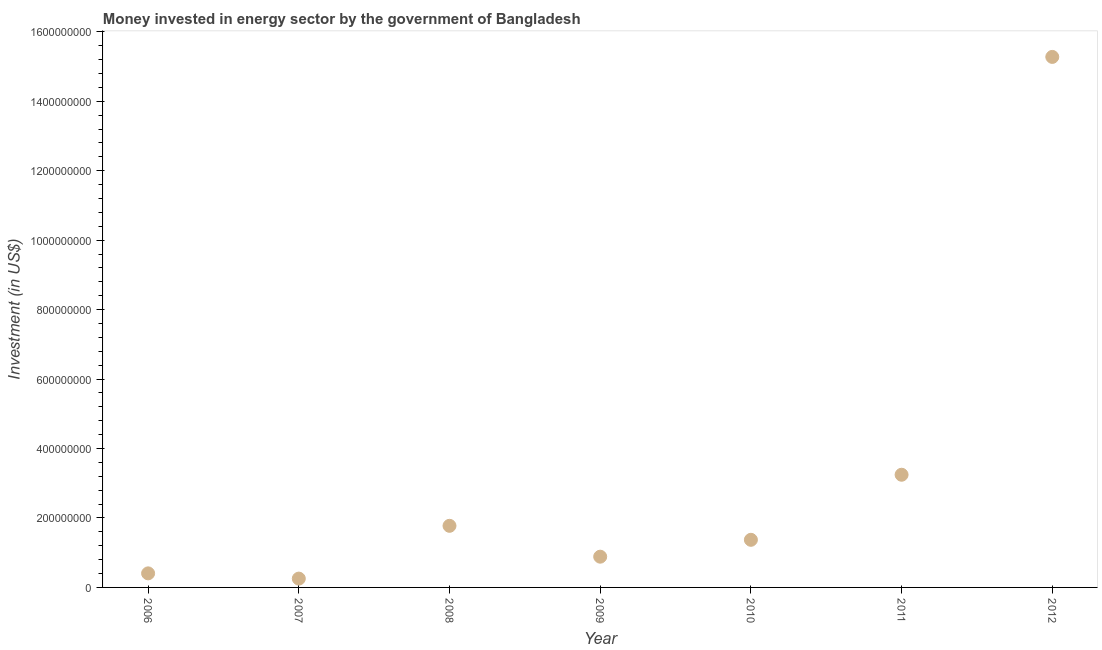What is the investment in energy in 2010?
Your answer should be very brief. 1.37e+08. Across all years, what is the maximum investment in energy?
Keep it short and to the point. 1.53e+09. Across all years, what is the minimum investment in energy?
Your answer should be compact. 2.54e+07. In which year was the investment in energy maximum?
Ensure brevity in your answer.  2012. In which year was the investment in energy minimum?
Keep it short and to the point. 2007. What is the sum of the investment in energy?
Make the answer very short. 2.32e+09. What is the difference between the investment in energy in 2006 and 2012?
Your answer should be very brief. -1.49e+09. What is the average investment in energy per year?
Offer a very short reply. 3.32e+08. What is the median investment in energy?
Offer a terse response. 1.37e+08. In how many years, is the investment in energy greater than 640000000 US$?
Provide a succinct answer. 1. What is the ratio of the investment in energy in 2007 to that in 2011?
Provide a short and direct response. 0.08. Is the investment in energy in 2007 less than that in 2008?
Your answer should be very brief. Yes. What is the difference between the highest and the second highest investment in energy?
Make the answer very short. 1.20e+09. Is the sum of the investment in energy in 2006 and 2007 greater than the maximum investment in energy across all years?
Keep it short and to the point. No. What is the difference between the highest and the lowest investment in energy?
Give a very brief answer. 1.50e+09. In how many years, is the investment in energy greater than the average investment in energy taken over all years?
Give a very brief answer. 1. How many years are there in the graph?
Make the answer very short. 7. What is the difference between two consecutive major ticks on the Y-axis?
Make the answer very short. 2.00e+08. Does the graph contain grids?
Give a very brief answer. No. What is the title of the graph?
Provide a short and direct response. Money invested in energy sector by the government of Bangladesh. What is the label or title of the X-axis?
Provide a succinct answer. Year. What is the label or title of the Y-axis?
Provide a short and direct response. Investment (in US$). What is the Investment (in US$) in 2006?
Offer a terse response. 4.05e+07. What is the Investment (in US$) in 2007?
Offer a terse response. 2.54e+07. What is the Investment (in US$) in 2008?
Your answer should be compact. 1.77e+08. What is the Investment (in US$) in 2009?
Offer a very short reply. 8.85e+07. What is the Investment (in US$) in 2010?
Offer a terse response. 1.37e+08. What is the Investment (in US$) in 2011?
Ensure brevity in your answer.  3.25e+08. What is the Investment (in US$) in 2012?
Your answer should be very brief. 1.53e+09. What is the difference between the Investment (in US$) in 2006 and 2007?
Your answer should be compact. 1.51e+07. What is the difference between the Investment (in US$) in 2006 and 2008?
Offer a terse response. -1.37e+08. What is the difference between the Investment (in US$) in 2006 and 2009?
Keep it short and to the point. -4.80e+07. What is the difference between the Investment (in US$) in 2006 and 2010?
Provide a succinct answer. -9.66e+07. What is the difference between the Investment (in US$) in 2006 and 2011?
Your answer should be very brief. -2.84e+08. What is the difference between the Investment (in US$) in 2006 and 2012?
Provide a succinct answer. -1.49e+09. What is the difference between the Investment (in US$) in 2007 and 2008?
Make the answer very short. -1.52e+08. What is the difference between the Investment (in US$) in 2007 and 2009?
Your response must be concise. -6.31e+07. What is the difference between the Investment (in US$) in 2007 and 2010?
Provide a short and direct response. -1.12e+08. What is the difference between the Investment (in US$) in 2007 and 2011?
Provide a succinct answer. -2.99e+08. What is the difference between the Investment (in US$) in 2007 and 2012?
Provide a short and direct response. -1.50e+09. What is the difference between the Investment (in US$) in 2008 and 2009?
Offer a very short reply. 8.89e+07. What is the difference between the Investment (in US$) in 2008 and 2010?
Your response must be concise. 4.03e+07. What is the difference between the Investment (in US$) in 2008 and 2011?
Your answer should be compact. -1.47e+08. What is the difference between the Investment (in US$) in 2008 and 2012?
Make the answer very short. -1.35e+09. What is the difference between the Investment (in US$) in 2009 and 2010?
Keep it short and to the point. -4.86e+07. What is the difference between the Investment (in US$) in 2009 and 2011?
Ensure brevity in your answer.  -2.36e+08. What is the difference between the Investment (in US$) in 2009 and 2012?
Offer a very short reply. -1.44e+09. What is the difference between the Investment (in US$) in 2010 and 2011?
Ensure brevity in your answer.  -1.87e+08. What is the difference between the Investment (in US$) in 2010 and 2012?
Give a very brief answer. -1.39e+09. What is the difference between the Investment (in US$) in 2011 and 2012?
Your answer should be compact. -1.20e+09. What is the ratio of the Investment (in US$) in 2006 to that in 2007?
Provide a succinct answer. 1.59. What is the ratio of the Investment (in US$) in 2006 to that in 2008?
Make the answer very short. 0.23. What is the ratio of the Investment (in US$) in 2006 to that in 2009?
Make the answer very short. 0.46. What is the ratio of the Investment (in US$) in 2006 to that in 2010?
Give a very brief answer. 0.29. What is the ratio of the Investment (in US$) in 2006 to that in 2012?
Offer a very short reply. 0.03. What is the ratio of the Investment (in US$) in 2007 to that in 2008?
Keep it short and to the point. 0.14. What is the ratio of the Investment (in US$) in 2007 to that in 2009?
Provide a succinct answer. 0.29. What is the ratio of the Investment (in US$) in 2007 to that in 2010?
Your answer should be very brief. 0.18. What is the ratio of the Investment (in US$) in 2007 to that in 2011?
Your response must be concise. 0.08. What is the ratio of the Investment (in US$) in 2007 to that in 2012?
Provide a succinct answer. 0.02. What is the ratio of the Investment (in US$) in 2008 to that in 2009?
Your answer should be very brief. 2. What is the ratio of the Investment (in US$) in 2008 to that in 2010?
Keep it short and to the point. 1.29. What is the ratio of the Investment (in US$) in 2008 to that in 2011?
Your answer should be compact. 0.55. What is the ratio of the Investment (in US$) in 2008 to that in 2012?
Your answer should be compact. 0.12. What is the ratio of the Investment (in US$) in 2009 to that in 2010?
Your answer should be very brief. 0.65. What is the ratio of the Investment (in US$) in 2009 to that in 2011?
Ensure brevity in your answer.  0.27. What is the ratio of the Investment (in US$) in 2009 to that in 2012?
Ensure brevity in your answer.  0.06. What is the ratio of the Investment (in US$) in 2010 to that in 2011?
Provide a short and direct response. 0.42. What is the ratio of the Investment (in US$) in 2010 to that in 2012?
Your answer should be very brief. 0.09. What is the ratio of the Investment (in US$) in 2011 to that in 2012?
Your answer should be very brief. 0.21. 